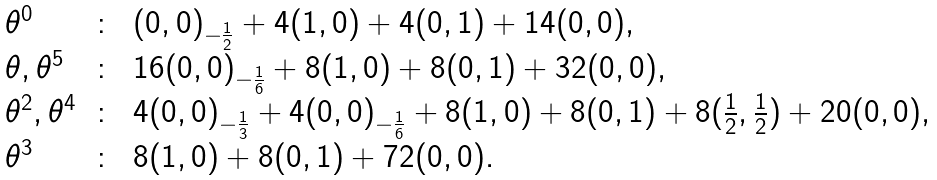<formula> <loc_0><loc_0><loc_500><loc_500>\begin{array} { l c l } \theta ^ { 0 } & \colon & ( 0 , 0 ) _ { - \frac { 1 } { 2 } } + 4 ( 1 , 0 ) + 4 ( 0 , 1 ) + 1 4 ( 0 , 0 ) , \\ \theta , \theta ^ { 5 } & \colon & 1 6 ( 0 , 0 ) _ { - \frac { 1 } { 6 } } + 8 ( 1 , 0 ) + 8 ( 0 , 1 ) + 3 2 ( 0 , 0 ) , \\ \theta ^ { 2 } , \theta ^ { 4 } & \colon & 4 ( 0 , 0 ) _ { - \frac { 1 } { 3 } } + 4 ( 0 , 0 ) _ { - \frac { 1 } { 6 } } + 8 ( 1 , 0 ) + 8 ( 0 , 1 ) + 8 ( \frac { 1 } { 2 } , \frac { 1 } { 2 } ) + 2 0 ( 0 , 0 ) , \\ \theta ^ { 3 } & \colon & 8 ( 1 , 0 ) + 8 ( 0 , 1 ) + 7 2 ( 0 , 0 ) . \end{array}</formula> 